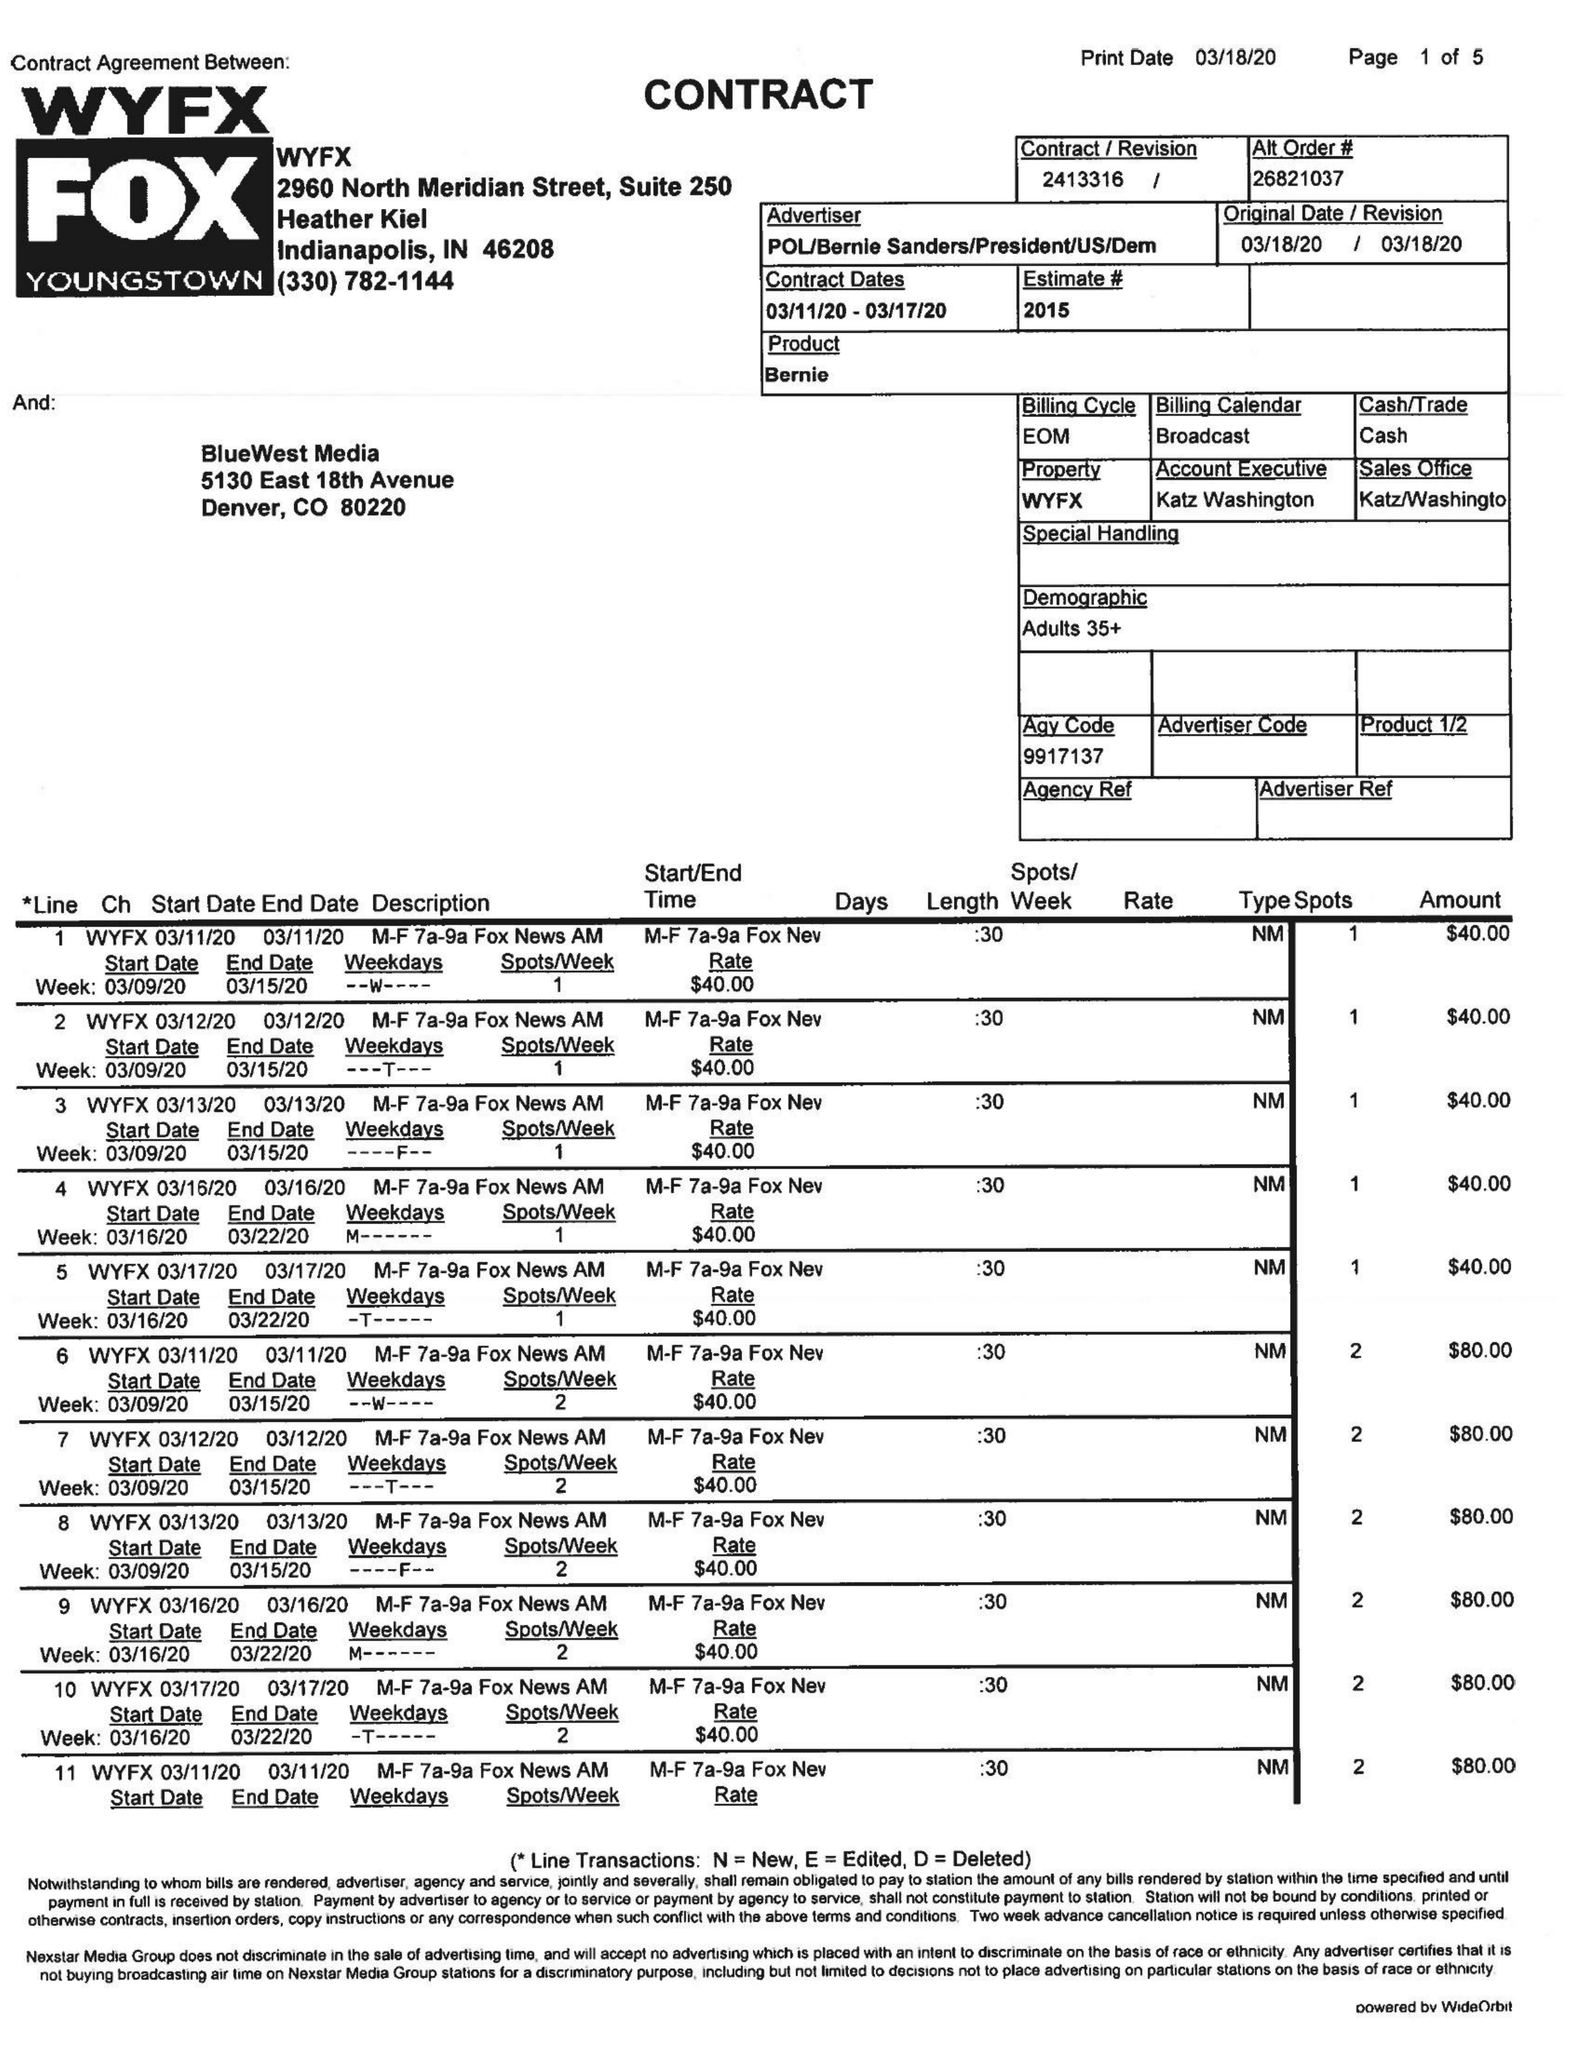What is the value for the flight_from?
Answer the question using a single word or phrase. 03/11/20 